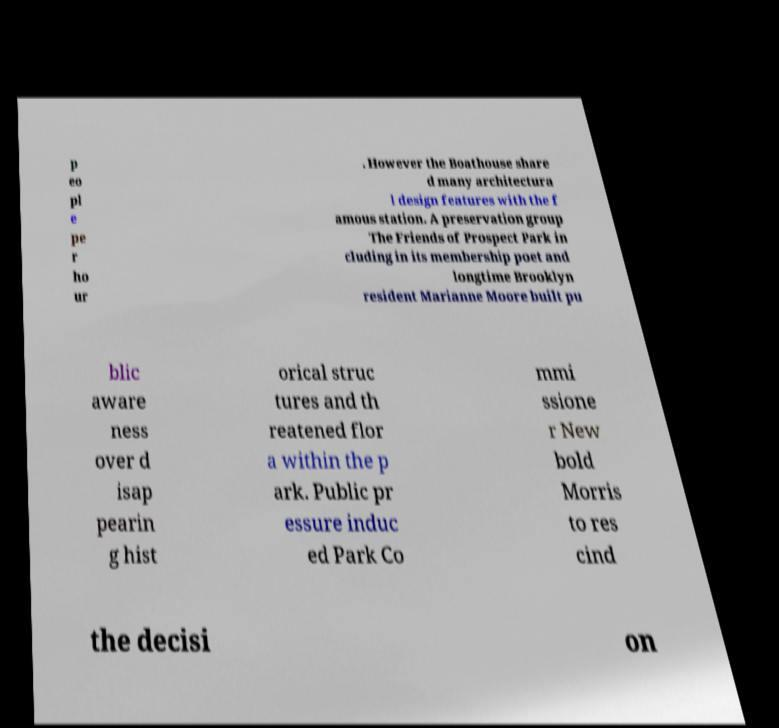There's text embedded in this image that I need extracted. Can you transcribe it verbatim? p eo pl e pe r ho ur . However the Boathouse share d many architectura l design features with the f amous station. A preservation group The Friends of Prospect Park in cluding in its membership poet and longtime Brooklyn resident Marianne Moore built pu blic aware ness over d isap pearin g hist orical struc tures and th reatened flor a within the p ark. Public pr essure induc ed Park Co mmi ssione r New bold Morris to res cind the decisi on 